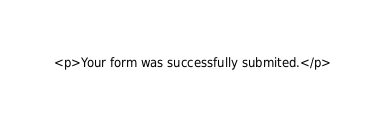<code> <loc_0><loc_0><loc_500><loc_500><_PHP_><p>Your form was successfully submited.</p></code> 